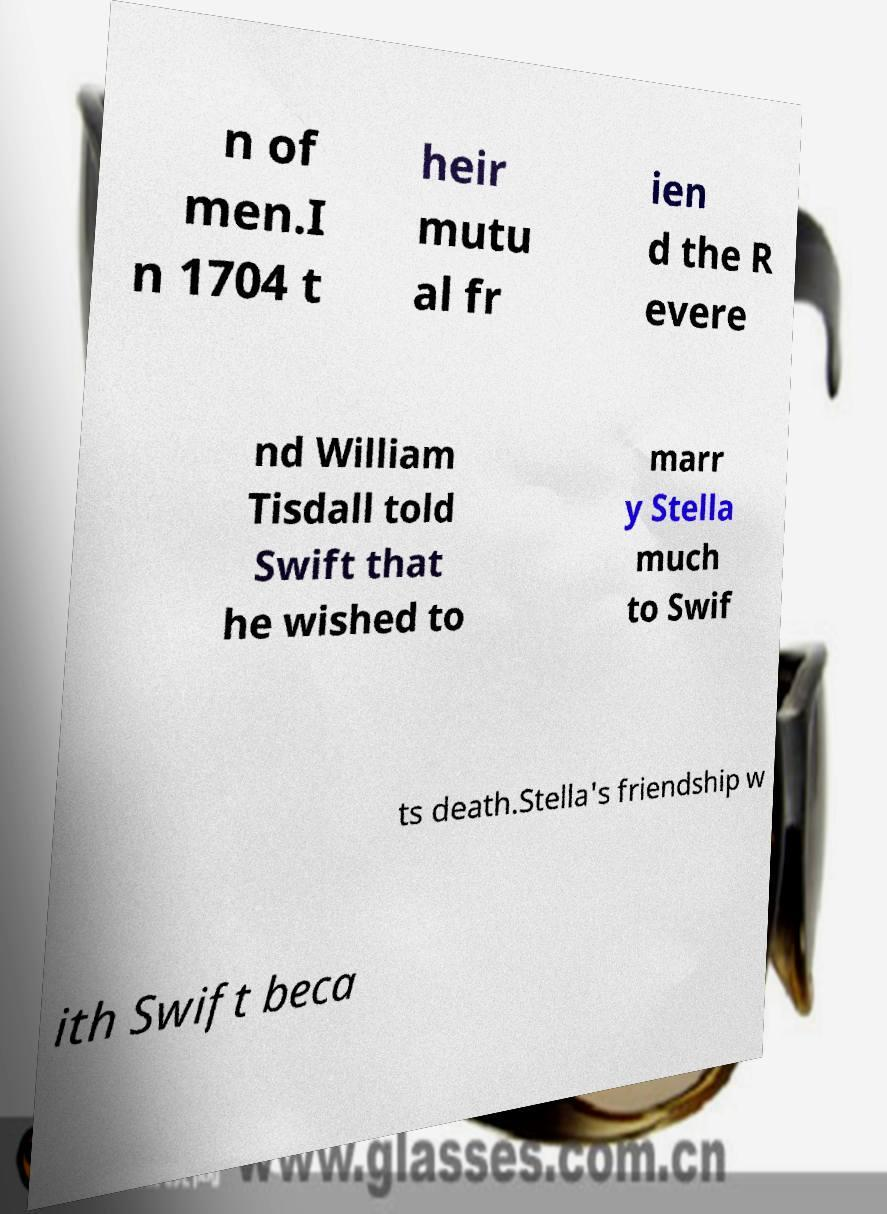I need the written content from this picture converted into text. Can you do that? n of men.I n 1704 t heir mutu al fr ien d the R evere nd William Tisdall told Swift that he wished to marr y Stella much to Swif ts death.Stella's friendship w ith Swift beca 